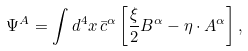Convert formula to latex. <formula><loc_0><loc_0><loc_500><loc_500>\Psi ^ { A } = \int d ^ { 4 } x \, \bar { c } ^ { \alpha } \left [ \frac { \xi } { 2 } B ^ { \alpha } - \eta \cdot A ^ { \alpha } \right ] ,</formula> 